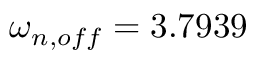Convert formula to latex. <formula><loc_0><loc_0><loc_500><loc_500>\omega _ { n , o f f } = 3 . 7 9 3 9</formula> 